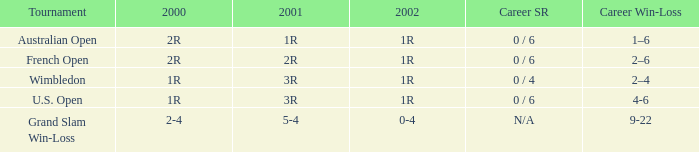In which 2000 competition did angeles montolio achieve a career victory-defeat ratio of 2-4? Grand Slam Win-Loss. 